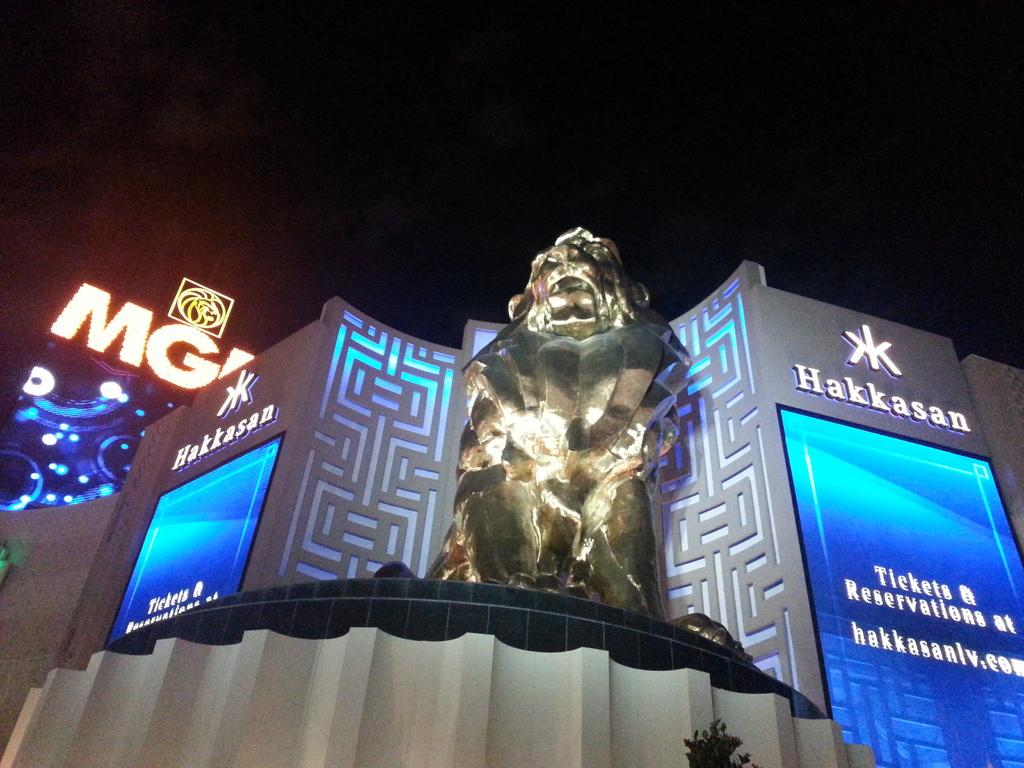Provide a one-sentence caption for the provided image. The outside of a building called Hakkasan with a stature in front. 